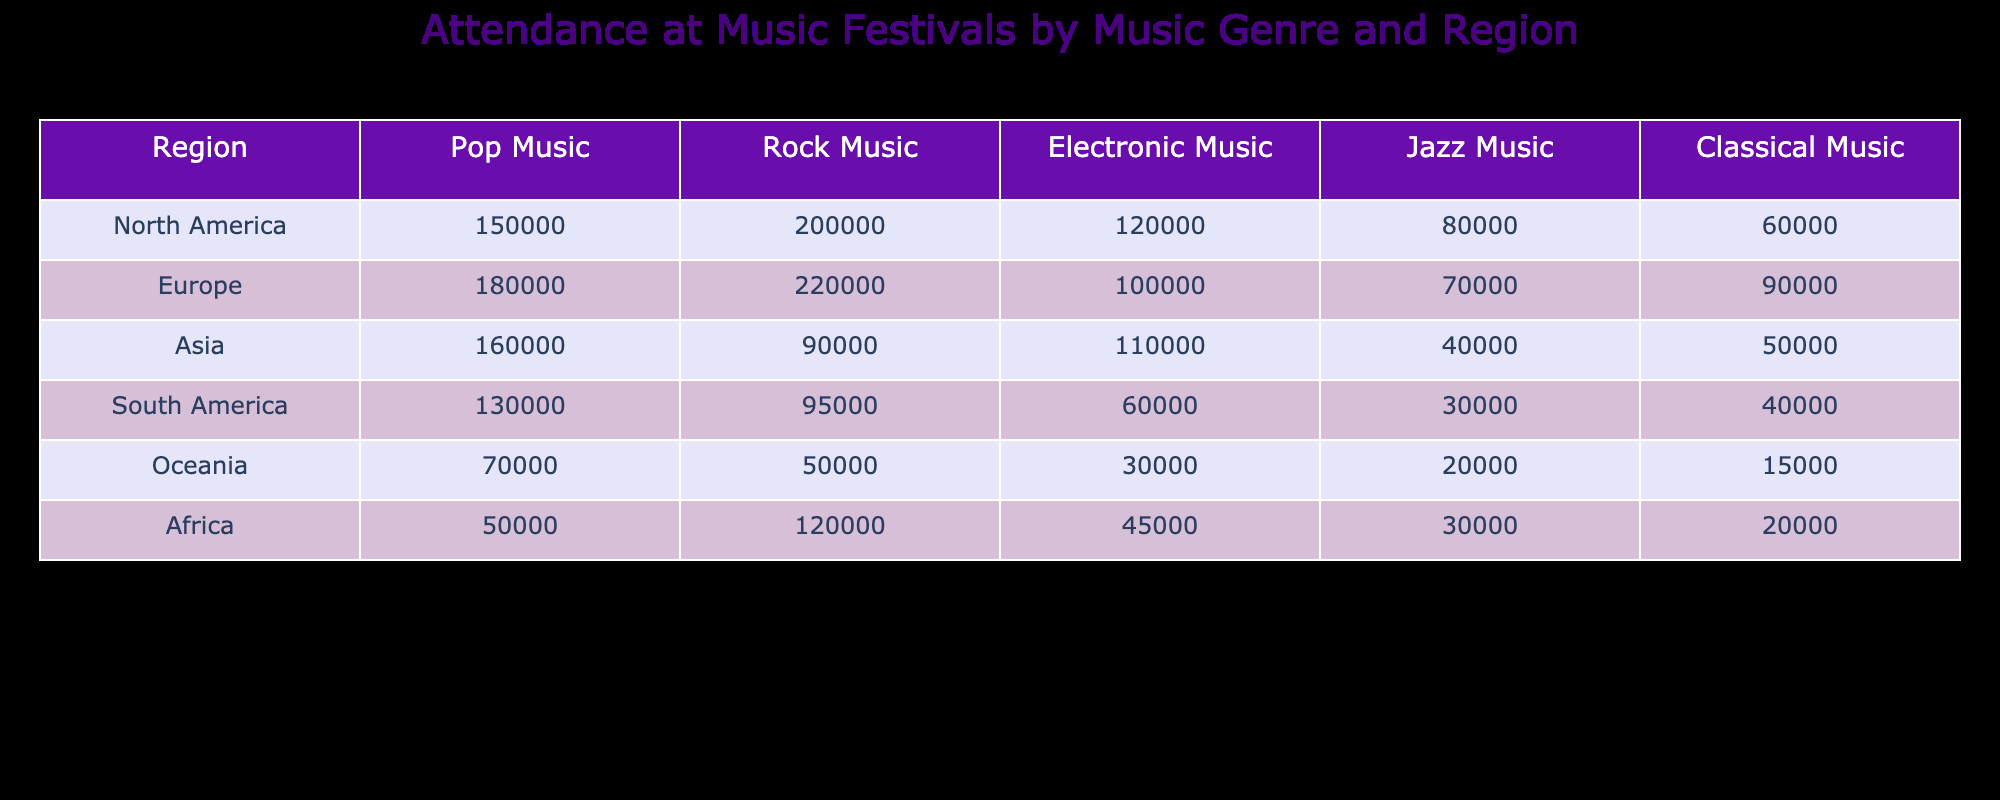What region has the highest attendance for pop music festivals? By inspecting the "Pop Music" column, the values for North America, Europe, Asia, South America, Oceania, and Africa are 150000, 180000, 160000, 130000, 70000, and 50000, respectively. The highest value is 180000 from Europe.
Answer: Europe Which genre has the lowest attendance in Oceania? Looking at the Oceania row, the attendance values for each genre are 70000 for Pop, 50000 for Rock, 30000 for Electronic, 20000 for Jazz, and 15000 for Classical. The lowest value is 15000 for Classical music.
Answer: Classical Music What is the total attendance for rock music in North America and Europe? The total attendance for rock music is the sum of the values from North America (200000) and Europe (220000). Adding these amounts gives 200000 + 220000 = 420000.
Answer: 420000 Is the attendance for electronic music in South America higher than in Asia? Checking the "Electronic Music" column, South America has 60000 while Asia has 110000. Since 60000 is less than 110000, the answer is no.
Answer: No What is the average attendance for jazz music across all regions? To find the average attendance for jazz music, we first gather the values: 80000 (North America), 70000 (Europe), 40000 (Asia), 30000 (South America), 20000 (Oceania), and 30000 (Africa). The total is 80000 + 70000 + 40000 + 30000 + 20000 + 30000 = 270000. There are 6 regions, so the average is 270000 / 6 = 45000.
Answer: 45000 Which region has a higher attendance for classical music: Europe or Africa? Upon assessing the "Classical Music" values, Europe has 90000 and Africa has 20000. Since 90000 is greater than 20000, Europe has a higher attendance.
Answer: Europe Calculate the difference in attendance between rock music and jazz music in Asia. In Asia, rock music attendance is 90000 and jazz music attendance is 40000. The difference is calculated as 90000 - 40000 = 50000.
Answer: 50000 Which music genre has the maximum attendance across all regions? By comparing the sums of all genres: Pop = 150000 + 180000 + 160000 + 130000 + 70000 + 50000 = 790000, Rock = 200000 + 220000 + 90000 + 95000 + 50000 + 120000 = 780000, Electronic = 120000 + 100000 + 110000 + 60000 + 30000 + 45000 = 425000, Jazz = 80000 + 70000 + 40000 + 30000 + 20000 + 30000 = 270000, Classical = 60000 + 90000 + 50000 + 40000 + 15000 + 20000 = 290000. Pop music has the highest total attendance of 790000.
Answer: Pop Music 